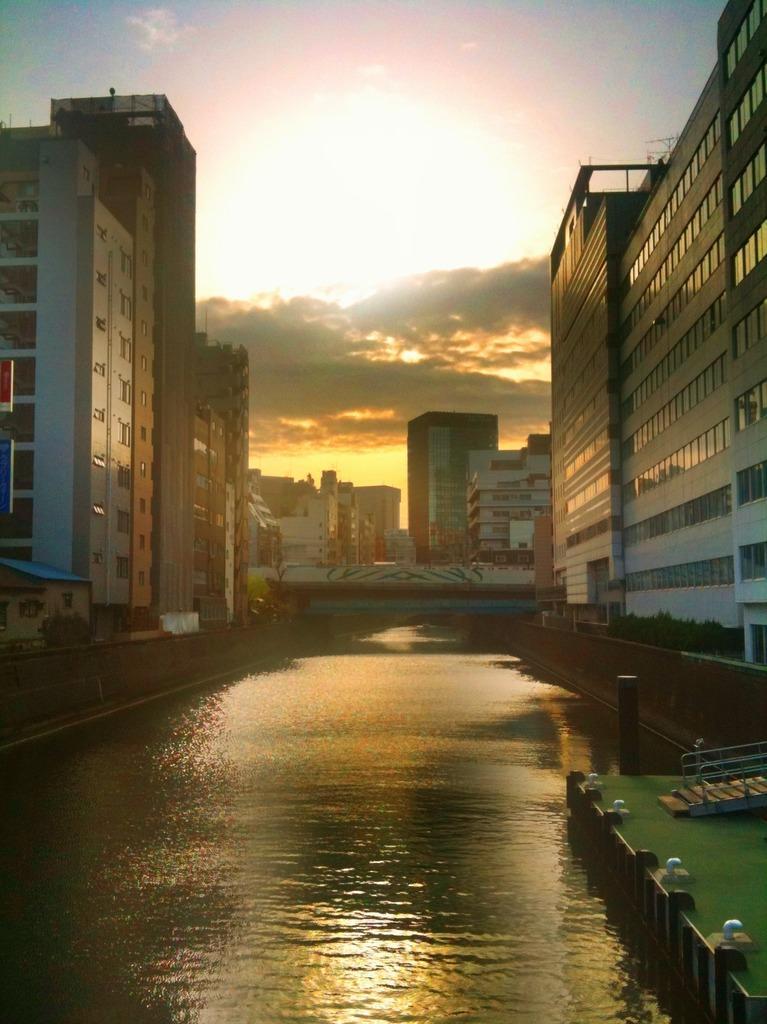Please provide a concise description of this image. In this picture I can observe a lake in the middle of the picture. There are buildings in this picture. In the background I can observe clouds in the sky. 